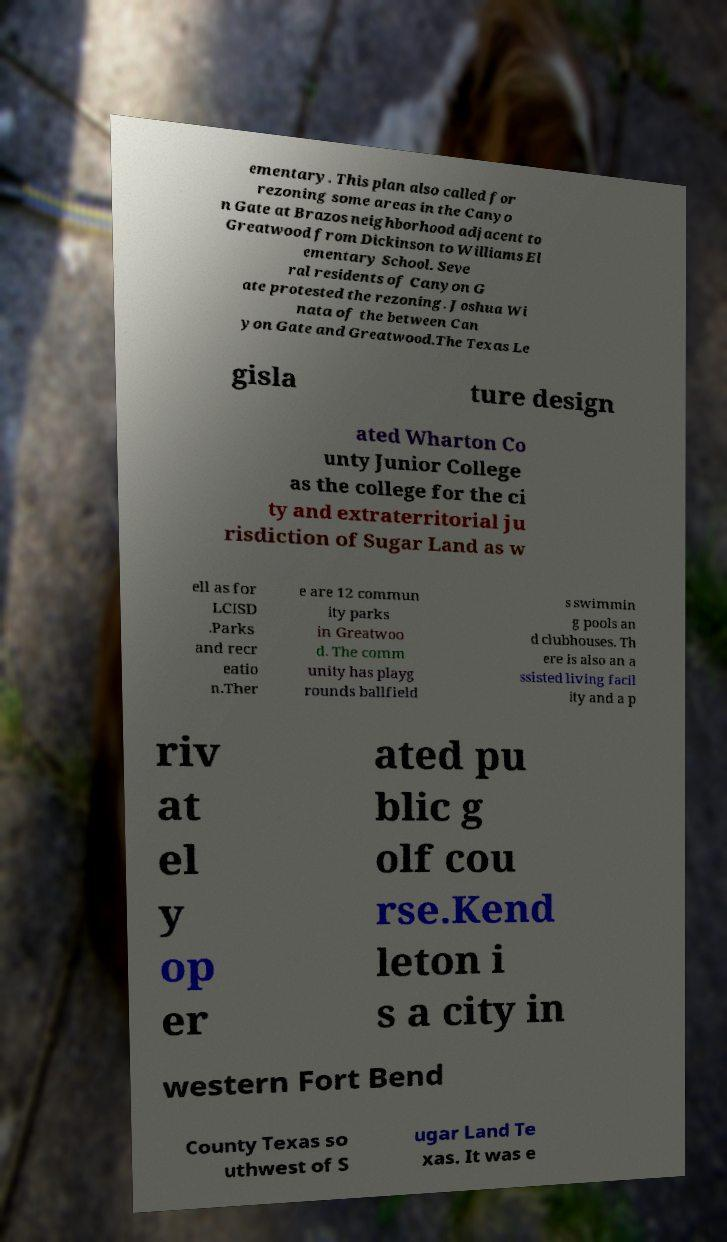Could you assist in decoding the text presented in this image and type it out clearly? ementary. This plan also called for rezoning some areas in the Canyo n Gate at Brazos neighborhood adjacent to Greatwood from Dickinson to Williams El ementary School. Seve ral residents of Canyon G ate protested the rezoning. Joshua Wi nata of the between Can yon Gate and Greatwood.The Texas Le gisla ture design ated Wharton Co unty Junior College as the college for the ci ty and extraterritorial ju risdiction of Sugar Land as w ell as for LCISD .Parks and recr eatio n.Ther e are 12 commun ity parks in Greatwoo d. The comm unity has playg rounds ballfield s swimmin g pools an d clubhouses. Th ere is also an a ssisted living facil ity and a p riv at el y op er ated pu blic g olf cou rse.Kend leton i s a city in western Fort Bend County Texas so uthwest of S ugar Land Te xas. It was e 